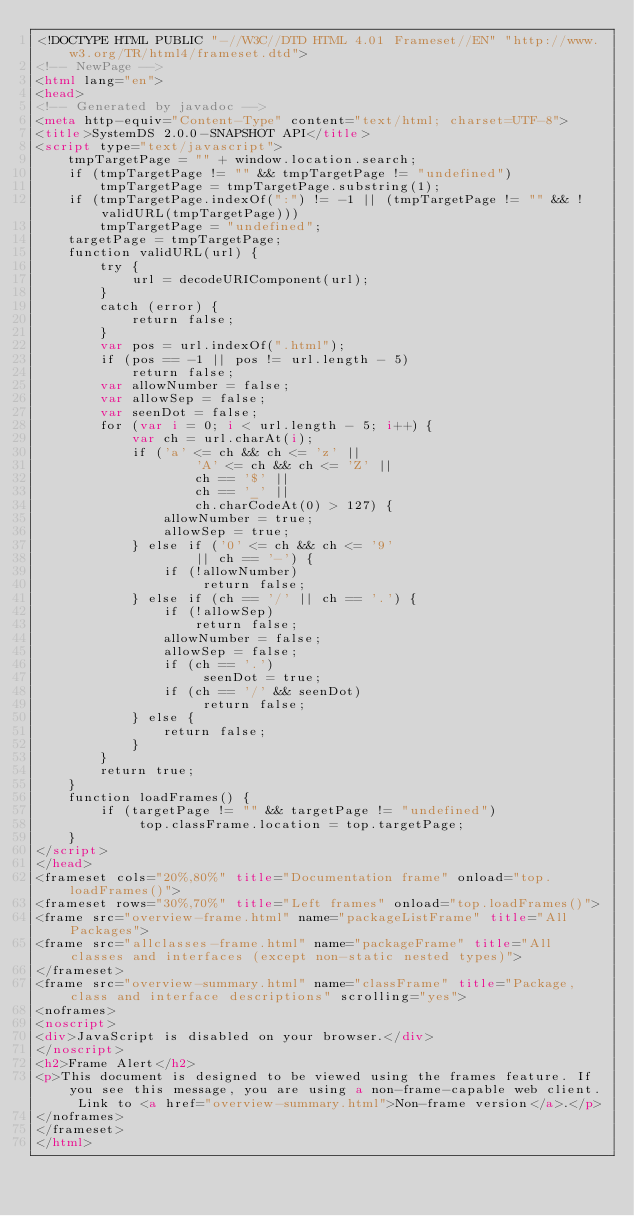<code> <loc_0><loc_0><loc_500><loc_500><_HTML_><!DOCTYPE HTML PUBLIC "-//W3C//DTD HTML 4.01 Frameset//EN" "http://www.w3.org/TR/html4/frameset.dtd">
<!-- NewPage -->
<html lang="en">
<head>
<!-- Generated by javadoc -->
<meta http-equiv="Content-Type" content="text/html; charset=UTF-8">
<title>SystemDS 2.0.0-SNAPSHOT API</title>
<script type="text/javascript">
    tmpTargetPage = "" + window.location.search;
    if (tmpTargetPage != "" && tmpTargetPage != "undefined")
        tmpTargetPage = tmpTargetPage.substring(1);
    if (tmpTargetPage.indexOf(":") != -1 || (tmpTargetPage != "" && !validURL(tmpTargetPage)))
        tmpTargetPage = "undefined";
    targetPage = tmpTargetPage;
    function validURL(url) {
        try {
            url = decodeURIComponent(url);
        }
        catch (error) {
            return false;
        }
        var pos = url.indexOf(".html");
        if (pos == -1 || pos != url.length - 5)
            return false;
        var allowNumber = false;
        var allowSep = false;
        var seenDot = false;
        for (var i = 0; i < url.length - 5; i++) {
            var ch = url.charAt(i);
            if ('a' <= ch && ch <= 'z' ||
                    'A' <= ch && ch <= 'Z' ||
                    ch == '$' ||
                    ch == '_' ||
                    ch.charCodeAt(0) > 127) {
                allowNumber = true;
                allowSep = true;
            } else if ('0' <= ch && ch <= '9'
                    || ch == '-') {
                if (!allowNumber)
                     return false;
            } else if (ch == '/' || ch == '.') {
                if (!allowSep)
                    return false;
                allowNumber = false;
                allowSep = false;
                if (ch == '.')
                     seenDot = true;
                if (ch == '/' && seenDot)
                     return false;
            } else {
                return false;
            }
        }
        return true;
    }
    function loadFrames() {
        if (targetPage != "" && targetPage != "undefined")
             top.classFrame.location = top.targetPage;
    }
</script>
</head>
<frameset cols="20%,80%" title="Documentation frame" onload="top.loadFrames()">
<frameset rows="30%,70%" title="Left frames" onload="top.loadFrames()">
<frame src="overview-frame.html" name="packageListFrame" title="All Packages">
<frame src="allclasses-frame.html" name="packageFrame" title="All classes and interfaces (except non-static nested types)">
</frameset>
<frame src="overview-summary.html" name="classFrame" title="Package, class and interface descriptions" scrolling="yes">
<noframes>
<noscript>
<div>JavaScript is disabled on your browser.</div>
</noscript>
<h2>Frame Alert</h2>
<p>This document is designed to be viewed using the frames feature. If you see this message, you are using a non-frame-capable web client. Link to <a href="overview-summary.html">Non-frame version</a>.</p>
</noframes>
</frameset>
</html>
</code> 